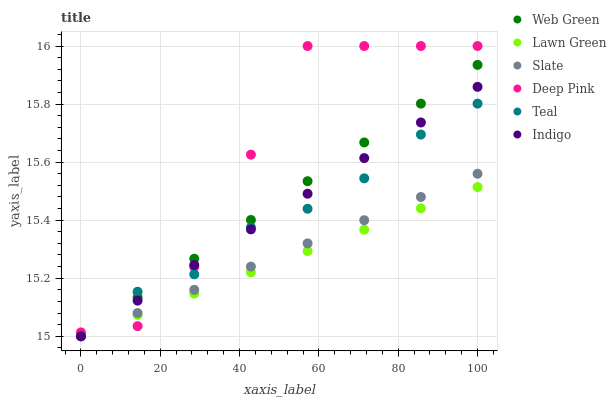Does Lawn Green have the minimum area under the curve?
Answer yes or no. Yes. Does Deep Pink have the maximum area under the curve?
Answer yes or no. Yes. Does Indigo have the minimum area under the curve?
Answer yes or no. No. Does Indigo have the maximum area under the curve?
Answer yes or no. No. Is Web Green the smoothest?
Answer yes or no. Yes. Is Deep Pink the roughest?
Answer yes or no. Yes. Is Indigo the smoothest?
Answer yes or no. No. Is Indigo the roughest?
Answer yes or no. No. Does Lawn Green have the lowest value?
Answer yes or no. Yes. Does Deep Pink have the lowest value?
Answer yes or no. No. Does Deep Pink have the highest value?
Answer yes or no. Yes. Does Indigo have the highest value?
Answer yes or no. No. Does Deep Pink intersect Indigo?
Answer yes or no. Yes. Is Deep Pink less than Indigo?
Answer yes or no. No. Is Deep Pink greater than Indigo?
Answer yes or no. No. 